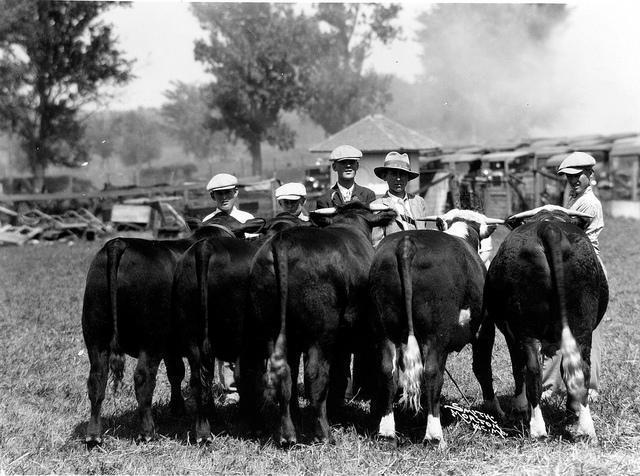How many hind legs are in this picture?
Give a very brief answer. 10. How many bulls are there?
Give a very brief answer. 5. How many people are there?
Give a very brief answer. 3. How many cows are in the picture?
Give a very brief answer. 5. How many umbrellas in the photo?
Give a very brief answer. 0. 